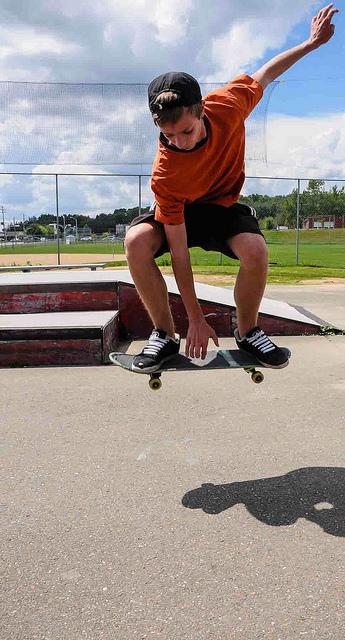What color is the helmet this boy is wearing?
Quick response, please. Black. How many skateboards are there?
Be succinct. 1. Is the man on the floor?
Be succinct. No. 